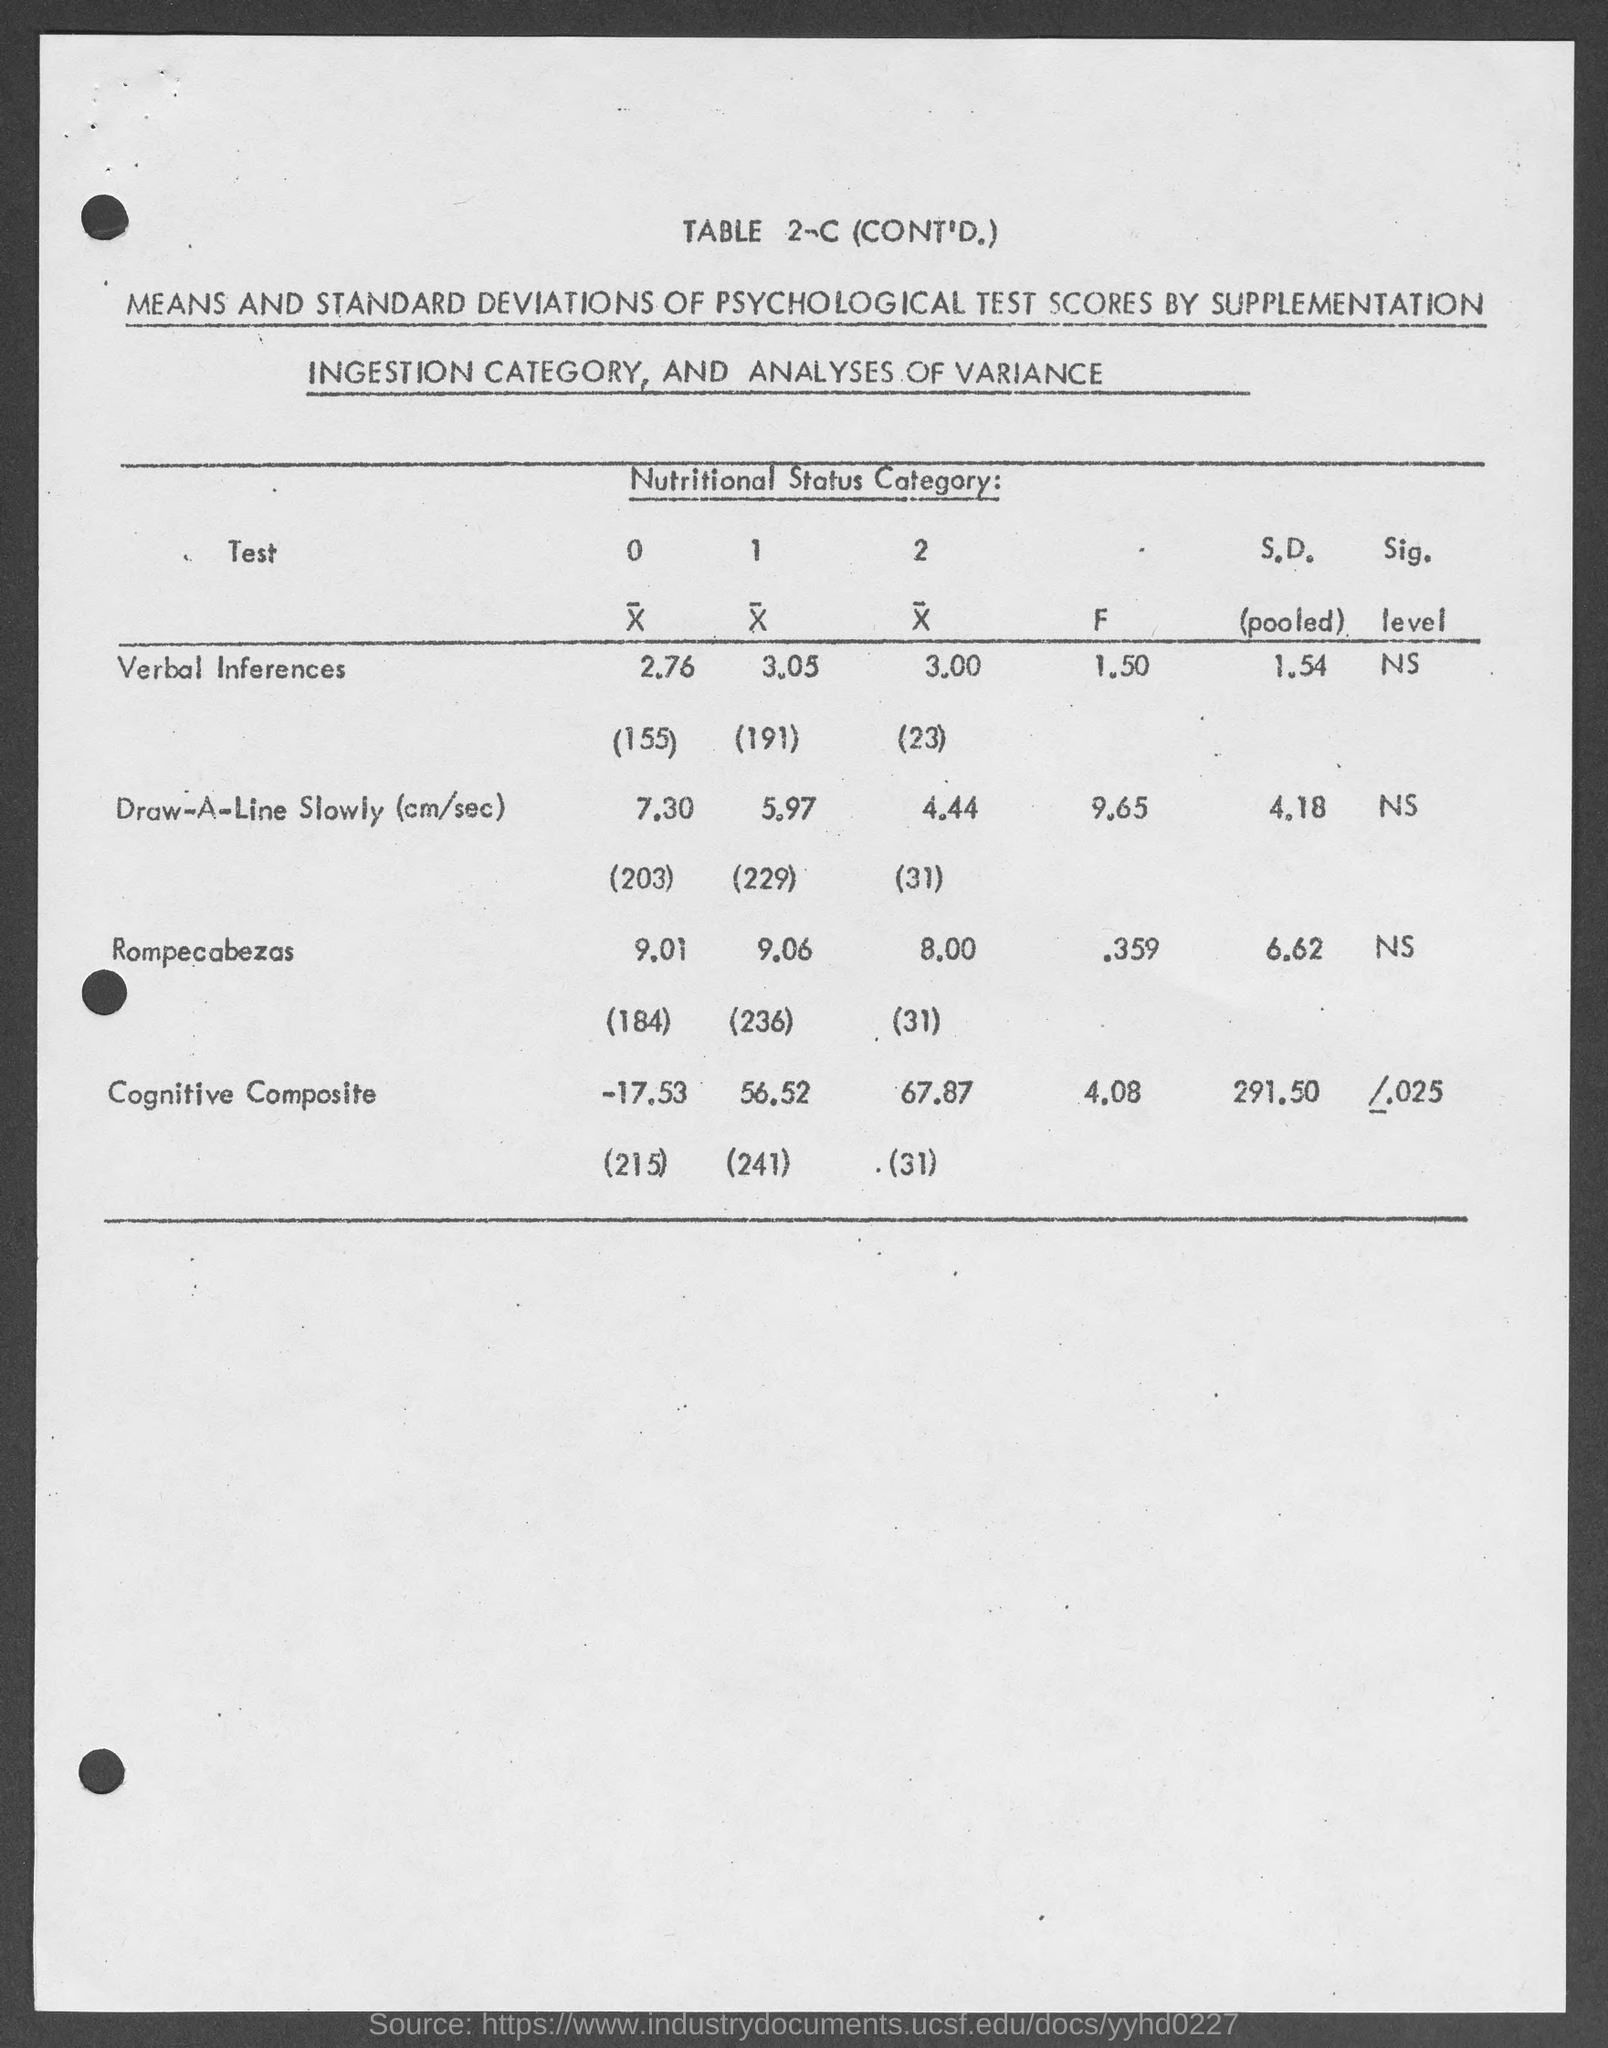Mention a couple of crucial points in this snapshot. The pooled standard deviation for the Draw-A-Line Slowly task was 4.18 centimeters per second. The F value for Rompecabezas is 0.359. The pooled standard deviation for the cognitive composite score is 291.50. What is the table number?" "Table 2-C. The pooled standard deviation for "Rompecabezas" is 6.62. 